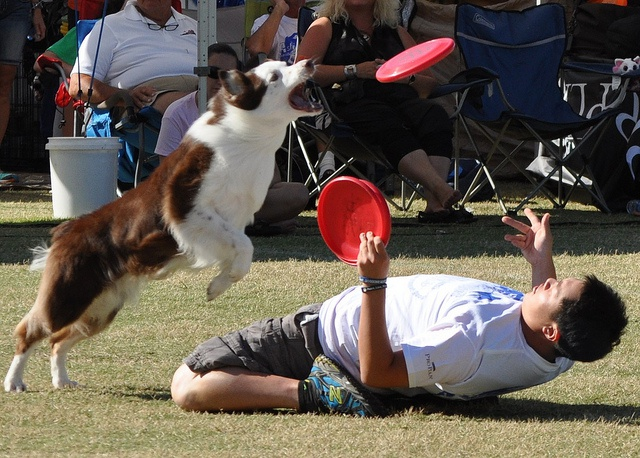Describe the objects in this image and their specific colors. I can see people in black, white, gray, and tan tones, dog in black, darkgray, maroon, and gray tones, chair in black, gray, and lightgray tones, people in black, maroon, and gray tones, and people in black, darkgray, and gray tones in this image. 